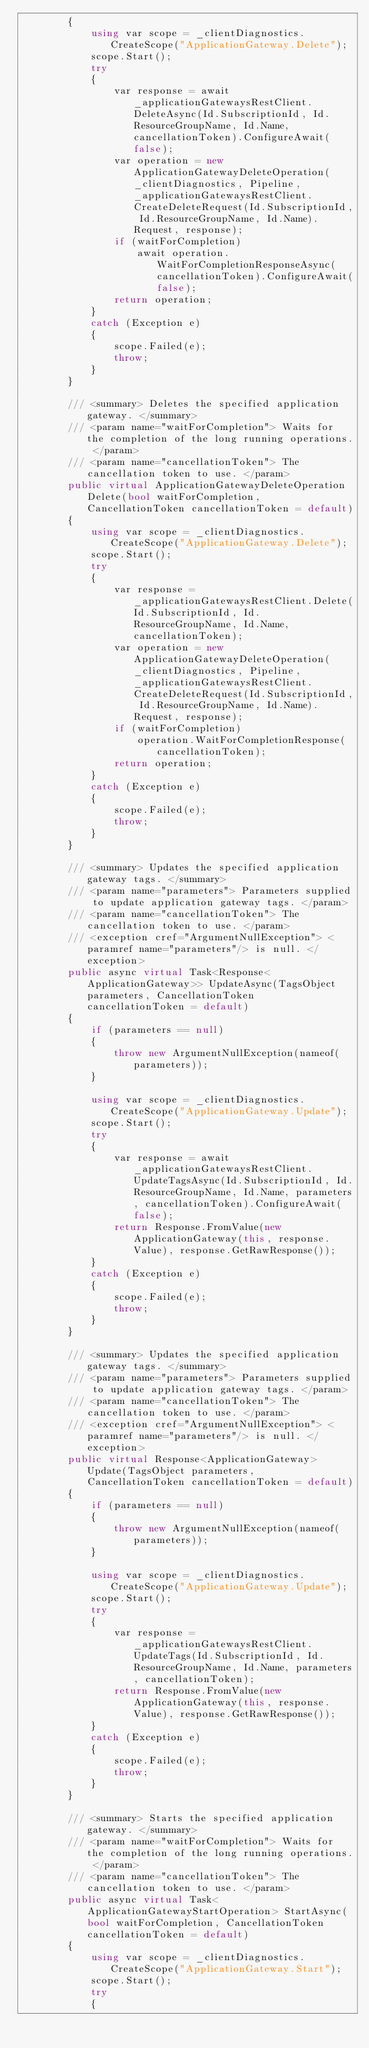Convert code to text. <code><loc_0><loc_0><loc_500><loc_500><_C#_>        {
            using var scope = _clientDiagnostics.CreateScope("ApplicationGateway.Delete");
            scope.Start();
            try
            {
                var response = await _applicationGatewaysRestClient.DeleteAsync(Id.SubscriptionId, Id.ResourceGroupName, Id.Name, cancellationToken).ConfigureAwait(false);
                var operation = new ApplicationGatewayDeleteOperation(_clientDiagnostics, Pipeline, _applicationGatewaysRestClient.CreateDeleteRequest(Id.SubscriptionId, Id.ResourceGroupName, Id.Name).Request, response);
                if (waitForCompletion)
                    await operation.WaitForCompletionResponseAsync(cancellationToken).ConfigureAwait(false);
                return operation;
            }
            catch (Exception e)
            {
                scope.Failed(e);
                throw;
            }
        }

        /// <summary> Deletes the specified application gateway. </summary>
        /// <param name="waitForCompletion"> Waits for the completion of the long running operations. </param>
        /// <param name="cancellationToken"> The cancellation token to use. </param>
        public virtual ApplicationGatewayDeleteOperation Delete(bool waitForCompletion, CancellationToken cancellationToken = default)
        {
            using var scope = _clientDiagnostics.CreateScope("ApplicationGateway.Delete");
            scope.Start();
            try
            {
                var response = _applicationGatewaysRestClient.Delete(Id.SubscriptionId, Id.ResourceGroupName, Id.Name, cancellationToken);
                var operation = new ApplicationGatewayDeleteOperation(_clientDiagnostics, Pipeline, _applicationGatewaysRestClient.CreateDeleteRequest(Id.SubscriptionId, Id.ResourceGroupName, Id.Name).Request, response);
                if (waitForCompletion)
                    operation.WaitForCompletionResponse(cancellationToken);
                return operation;
            }
            catch (Exception e)
            {
                scope.Failed(e);
                throw;
            }
        }

        /// <summary> Updates the specified application gateway tags. </summary>
        /// <param name="parameters"> Parameters supplied to update application gateway tags. </param>
        /// <param name="cancellationToken"> The cancellation token to use. </param>
        /// <exception cref="ArgumentNullException"> <paramref name="parameters"/> is null. </exception>
        public async virtual Task<Response<ApplicationGateway>> UpdateAsync(TagsObject parameters, CancellationToken cancellationToken = default)
        {
            if (parameters == null)
            {
                throw new ArgumentNullException(nameof(parameters));
            }

            using var scope = _clientDiagnostics.CreateScope("ApplicationGateway.Update");
            scope.Start();
            try
            {
                var response = await _applicationGatewaysRestClient.UpdateTagsAsync(Id.SubscriptionId, Id.ResourceGroupName, Id.Name, parameters, cancellationToken).ConfigureAwait(false);
                return Response.FromValue(new ApplicationGateway(this, response.Value), response.GetRawResponse());
            }
            catch (Exception e)
            {
                scope.Failed(e);
                throw;
            }
        }

        /// <summary> Updates the specified application gateway tags. </summary>
        /// <param name="parameters"> Parameters supplied to update application gateway tags. </param>
        /// <param name="cancellationToken"> The cancellation token to use. </param>
        /// <exception cref="ArgumentNullException"> <paramref name="parameters"/> is null. </exception>
        public virtual Response<ApplicationGateway> Update(TagsObject parameters, CancellationToken cancellationToken = default)
        {
            if (parameters == null)
            {
                throw new ArgumentNullException(nameof(parameters));
            }

            using var scope = _clientDiagnostics.CreateScope("ApplicationGateway.Update");
            scope.Start();
            try
            {
                var response = _applicationGatewaysRestClient.UpdateTags(Id.SubscriptionId, Id.ResourceGroupName, Id.Name, parameters, cancellationToken);
                return Response.FromValue(new ApplicationGateway(this, response.Value), response.GetRawResponse());
            }
            catch (Exception e)
            {
                scope.Failed(e);
                throw;
            }
        }

        /// <summary> Starts the specified application gateway. </summary>
        /// <param name="waitForCompletion"> Waits for the completion of the long running operations. </param>
        /// <param name="cancellationToken"> The cancellation token to use. </param>
        public async virtual Task<ApplicationGatewayStartOperation> StartAsync(bool waitForCompletion, CancellationToken cancellationToken = default)
        {
            using var scope = _clientDiagnostics.CreateScope("ApplicationGateway.Start");
            scope.Start();
            try
            {</code> 